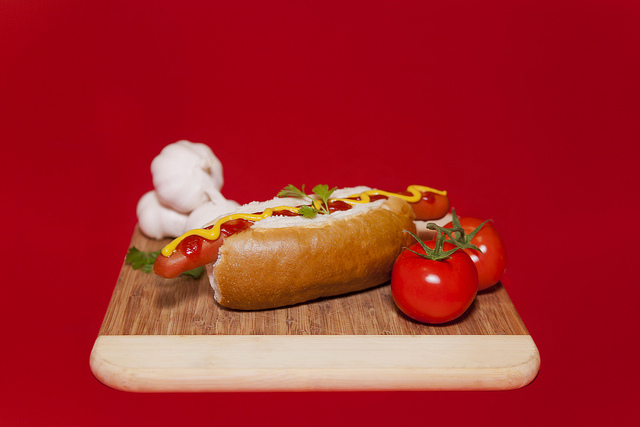What is the hot dog on top of? The hot dog is placed on top of a wooden cutting board, which adds an additional rustic touch to the presentation. 